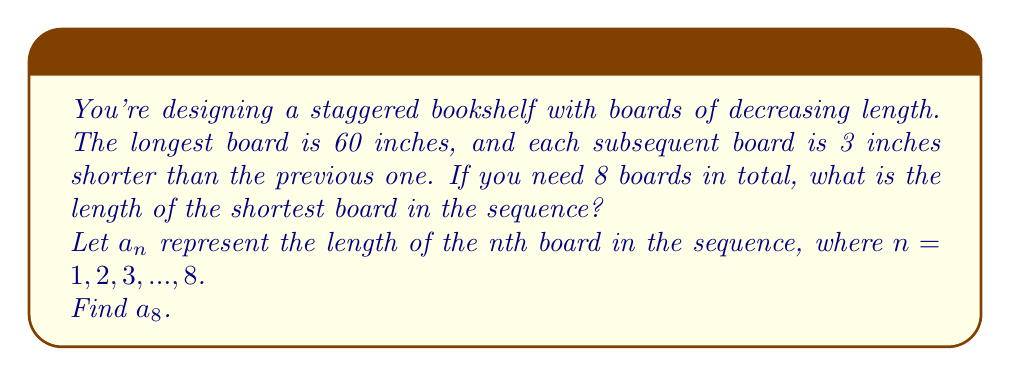What is the answer to this math problem? To solve this problem, we'll follow these steps:

1) Identify the sequence:
   This is an arithmetic sequence with a common difference of -3 inches.

2) Write the general term of the sequence:
   $a_n = a_1 + (n-1)d$
   Where $a_1 = 60$ (the first term) and $d = -3$ (the common difference)

3) Substitute the values:
   $a_n = 60 + (n-1)(-3)$
   $a_n = 60 - 3n + 3$
   $a_n = 63 - 3n$

4) Find the 8th term:
   $a_8 = 63 - 3(8)$
   $a_8 = 63 - 24$
   $a_8 = 39$

Therefore, the length of the shortest board (the 8th board) is 39 inches.
Answer: 39 inches 